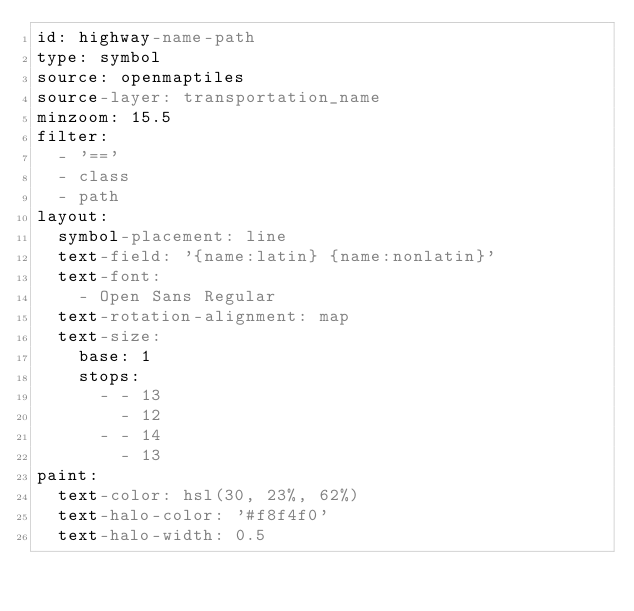Convert code to text. <code><loc_0><loc_0><loc_500><loc_500><_YAML_>id: highway-name-path
type: symbol
source: openmaptiles
source-layer: transportation_name
minzoom: 15.5
filter:
  - '=='
  - class
  - path
layout:
  symbol-placement: line
  text-field: '{name:latin} {name:nonlatin}'
  text-font:
    - Open Sans Regular
  text-rotation-alignment: map
  text-size:
    base: 1
    stops:
      - - 13
        - 12
      - - 14
        - 13
paint:
  text-color: hsl(30, 23%, 62%)
  text-halo-color: '#f8f4f0'
  text-halo-width: 0.5
</code> 